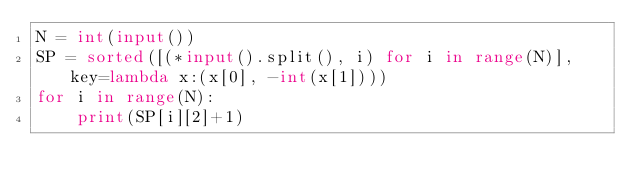<code> <loc_0><loc_0><loc_500><loc_500><_Python_>N = int(input())
SP = sorted([(*input().split(), i) for i in range(N)], key=lambda x:(x[0], -int(x[1])))
for i in range(N):
    print(SP[i][2]+1)</code> 